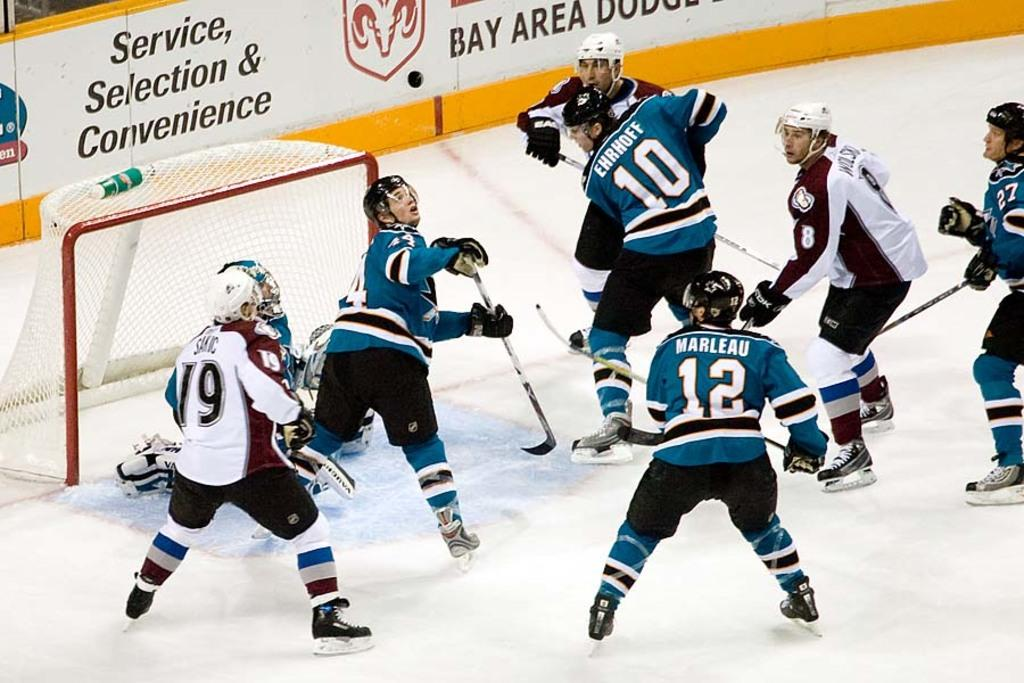Provide a one-sentence caption for the provided image. Hockey players scramble after the puck on a rink which is partially sponsored by a Bay area Dodge dealership. 